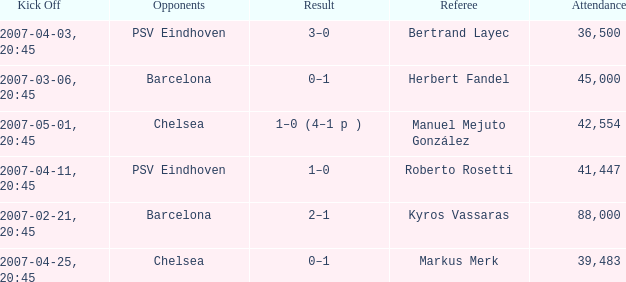WHAT WAS THE SCORE OF THE GAME WITH A 2007-03-06, 20:45 KICKOFF? 0–1. 